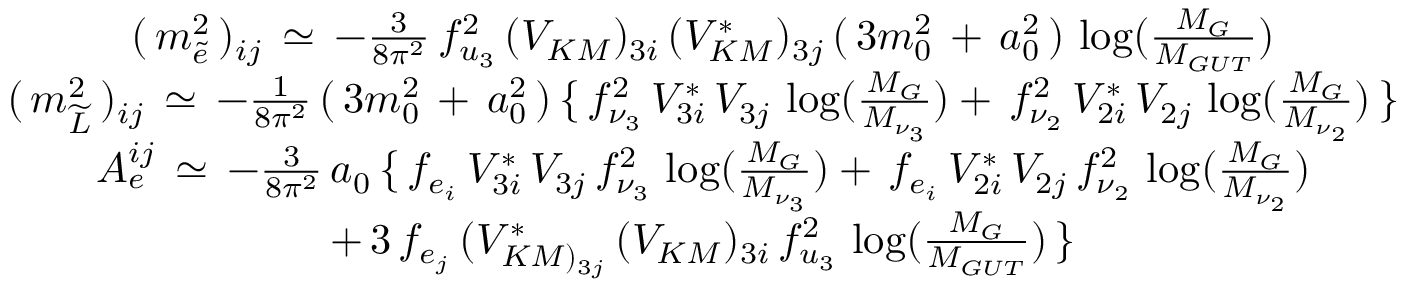Convert formula to latex. <formula><loc_0><loc_0><loc_500><loc_500>\begin{array} { c } { { ( \, m _ { \widetilde { e } } ^ { 2 } \, ) _ { i j } \, \simeq \, - \frac { 3 } { 8 \pi ^ { 2 } } \, f _ { u _ { 3 } } ^ { 2 } \, ( V _ { K M } ) _ { 3 i } \, ( V _ { K M } ^ { * } ) _ { 3 j } \, ( \, 3 m _ { 0 } ^ { 2 } \, + \, a _ { 0 } ^ { 2 } \, ) \, \log ( \frac { M _ { G } } { M _ { G U T } } ) } } \\ { { ( \, m _ { \widetilde { L } } ^ { 2 } \, ) _ { i j } \, \simeq \, - \frac { 1 } { 8 \pi ^ { 2 } } \, ( \, 3 m _ { 0 } ^ { 2 } \, + \, a _ { 0 } ^ { 2 } \, ) \, \{ \, f _ { \nu _ { 3 } } ^ { 2 } \, V _ { 3 i } ^ { * } \, V _ { 3 j } \, \log ( \frac { M _ { G } } { M _ { \nu _ { 3 } } } ) + \, f _ { \nu _ { 2 } } ^ { 2 } \, V _ { 2 i } ^ { * } \, V _ { 2 j } \, \log ( \frac { M _ { G } } { M _ { \nu _ { 2 } } } ) \, \} } } \\ { { A _ { e } ^ { i j } \, \simeq \, - \frac { 3 } { 8 \pi ^ { 2 } } \, a _ { 0 } \, \{ \, f _ { e _ { i } } \, V _ { 3 i } ^ { * } \, V _ { 3 j } \, f _ { \nu _ { 3 } } ^ { 2 } \, \log ( \frac { M _ { G } } { M _ { \nu _ { 3 } } } ) + \, f _ { e _ { i } } \, V _ { 2 i } ^ { * } \, V _ { 2 j } \, f _ { \nu _ { 2 } } ^ { 2 } \, \log ( \frac { M _ { G } } { M _ { \nu _ { 2 } } } ) } } \\ { { + \, 3 \, f _ { e _ { j } } \, ( V _ { K M ) _ { 3 j } } ^ { * } \, ( V _ { K M } ) _ { 3 i } \, f _ { u _ { 3 } } ^ { 2 } \, \log ( \frac { M _ { G } } { M _ { G U T } } ) \, \} } } \end{array}</formula> 